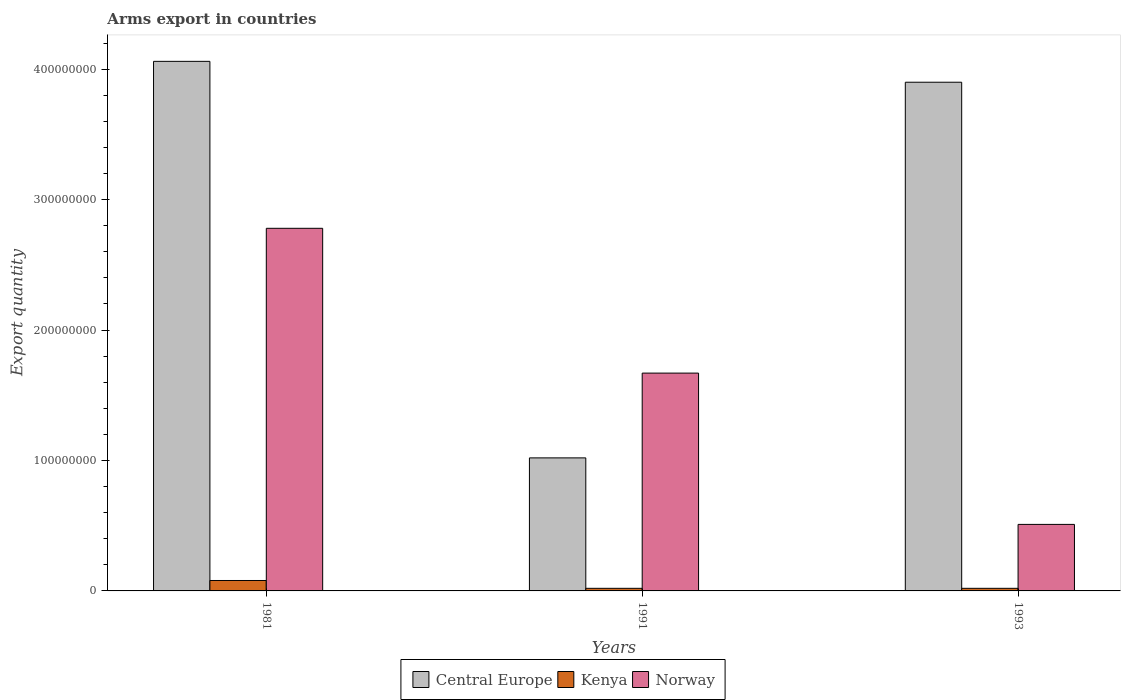How many different coloured bars are there?
Make the answer very short. 3. How many groups of bars are there?
Provide a succinct answer. 3. In how many cases, is the number of bars for a given year not equal to the number of legend labels?
Offer a very short reply. 0. What is the total arms export in Kenya in 1991?
Make the answer very short. 2.00e+06. Across all years, what is the minimum total arms export in Norway?
Provide a succinct answer. 5.10e+07. In which year was the total arms export in Norway maximum?
Your answer should be very brief. 1981. In which year was the total arms export in Central Europe minimum?
Ensure brevity in your answer.  1991. What is the total total arms export in Central Europe in the graph?
Keep it short and to the point. 8.98e+08. What is the difference between the total arms export in Central Europe in 1981 and that in 1991?
Ensure brevity in your answer.  3.04e+08. What is the difference between the total arms export in Kenya in 1981 and the total arms export in Norway in 1991?
Your answer should be very brief. -1.59e+08. What is the average total arms export in Central Europe per year?
Keep it short and to the point. 2.99e+08. In the year 1981, what is the difference between the total arms export in Central Europe and total arms export in Norway?
Offer a terse response. 1.28e+08. What is the ratio of the total arms export in Central Europe in 1981 to that in 1991?
Your answer should be very brief. 3.98. Is the total arms export in Kenya in 1981 less than that in 1991?
Your answer should be very brief. No. What is the difference between the highest and the lowest total arms export in Norway?
Your response must be concise. 2.27e+08. In how many years, is the total arms export in Central Europe greater than the average total arms export in Central Europe taken over all years?
Your answer should be very brief. 2. Is the sum of the total arms export in Central Europe in 1991 and 1993 greater than the maximum total arms export in Kenya across all years?
Offer a terse response. Yes. What does the 1st bar from the left in 1991 represents?
Your response must be concise. Central Europe. What does the 3rd bar from the right in 1981 represents?
Your answer should be compact. Central Europe. Is it the case that in every year, the sum of the total arms export in Norway and total arms export in Kenya is greater than the total arms export in Central Europe?
Give a very brief answer. No. Are all the bars in the graph horizontal?
Make the answer very short. No. Are the values on the major ticks of Y-axis written in scientific E-notation?
Offer a terse response. No. Does the graph contain grids?
Keep it short and to the point. No. Where does the legend appear in the graph?
Keep it short and to the point. Bottom center. How many legend labels are there?
Give a very brief answer. 3. How are the legend labels stacked?
Make the answer very short. Horizontal. What is the title of the graph?
Keep it short and to the point. Arms export in countries. What is the label or title of the Y-axis?
Offer a very short reply. Export quantity. What is the Export quantity in Central Europe in 1981?
Provide a succinct answer. 4.06e+08. What is the Export quantity of Norway in 1981?
Offer a very short reply. 2.78e+08. What is the Export quantity of Central Europe in 1991?
Offer a very short reply. 1.02e+08. What is the Export quantity in Kenya in 1991?
Provide a short and direct response. 2.00e+06. What is the Export quantity of Norway in 1991?
Make the answer very short. 1.67e+08. What is the Export quantity of Central Europe in 1993?
Provide a succinct answer. 3.90e+08. What is the Export quantity of Norway in 1993?
Your answer should be very brief. 5.10e+07. Across all years, what is the maximum Export quantity of Central Europe?
Your response must be concise. 4.06e+08. Across all years, what is the maximum Export quantity in Kenya?
Keep it short and to the point. 8.00e+06. Across all years, what is the maximum Export quantity in Norway?
Offer a terse response. 2.78e+08. Across all years, what is the minimum Export quantity of Central Europe?
Your answer should be very brief. 1.02e+08. Across all years, what is the minimum Export quantity of Norway?
Make the answer very short. 5.10e+07. What is the total Export quantity in Central Europe in the graph?
Give a very brief answer. 8.98e+08. What is the total Export quantity in Kenya in the graph?
Provide a succinct answer. 1.20e+07. What is the total Export quantity of Norway in the graph?
Offer a terse response. 4.96e+08. What is the difference between the Export quantity in Central Europe in 1981 and that in 1991?
Keep it short and to the point. 3.04e+08. What is the difference between the Export quantity of Norway in 1981 and that in 1991?
Keep it short and to the point. 1.11e+08. What is the difference between the Export quantity of Central Europe in 1981 and that in 1993?
Your answer should be very brief. 1.60e+07. What is the difference between the Export quantity of Kenya in 1981 and that in 1993?
Provide a short and direct response. 6.00e+06. What is the difference between the Export quantity in Norway in 1981 and that in 1993?
Your answer should be compact. 2.27e+08. What is the difference between the Export quantity in Central Europe in 1991 and that in 1993?
Keep it short and to the point. -2.88e+08. What is the difference between the Export quantity in Norway in 1991 and that in 1993?
Offer a terse response. 1.16e+08. What is the difference between the Export quantity of Central Europe in 1981 and the Export quantity of Kenya in 1991?
Provide a short and direct response. 4.04e+08. What is the difference between the Export quantity in Central Europe in 1981 and the Export quantity in Norway in 1991?
Your response must be concise. 2.39e+08. What is the difference between the Export quantity of Kenya in 1981 and the Export quantity of Norway in 1991?
Ensure brevity in your answer.  -1.59e+08. What is the difference between the Export quantity in Central Europe in 1981 and the Export quantity in Kenya in 1993?
Your response must be concise. 4.04e+08. What is the difference between the Export quantity in Central Europe in 1981 and the Export quantity in Norway in 1993?
Keep it short and to the point. 3.55e+08. What is the difference between the Export quantity of Kenya in 1981 and the Export quantity of Norway in 1993?
Ensure brevity in your answer.  -4.30e+07. What is the difference between the Export quantity in Central Europe in 1991 and the Export quantity in Kenya in 1993?
Ensure brevity in your answer.  1.00e+08. What is the difference between the Export quantity in Central Europe in 1991 and the Export quantity in Norway in 1993?
Offer a very short reply. 5.10e+07. What is the difference between the Export quantity in Kenya in 1991 and the Export quantity in Norway in 1993?
Make the answer very short. -4.90e+07. What is the average Export quantity in Central Europe per year?
Offer a terse response. 2.99e+08. What is the average Export quantity of Kenya per year?
Offer a terse response. 4.00e+06. What is the average Export quantity in Norway per year?
Offer a terse response. 1.65e+08. In the year 1981, what is the difference between the Export quantity of Central Europe and Export quantity of Kenya?
Give a very brief answer. 3.98e+08. In the year 1981, what is the difference between the Export quantity in Central Europe and Export quantity in Norway?
Ensure brevity in your answer.  1.28e+08. In the year 1981, what is the difference between the Export quantity in Kenya and Export quantity in Norway?
Keep it short and to the point. -2.70e+08. In the year 1991, what is the difference between the Export quantity of Central Europe and Export quantity of Norway?
Your answer should be very brief. -6.50e+07. In the year 1991, what is the difference between the Export quantity in Kenya and Export quantity in Norway?
Your answer should be very brief. -1.65e+08. In the year 1993, what is the difference between the Export quantity of Central Europe and Export quantity of Kenya?
Provide a succinct answer. 3.88e+08. In the year 1993, what is the difference between the Export quantity in Central Europe and Export quantity in Norway?
Offer a very short reply. 3.39e+08. In the year 1993, what is the difference between the Export quantity of Kenya and Export quantity of Norway?
Your answer should be very brief. -4.90e+07. What is the ratio of the Export quantity in Central Europe in 1981 to that in 1991?
Your response must be concise. 3.98. What is the ratio of the Export quantity of Kenya in 1981 to that in 1991?
Offer a very short reply. 4. What is the ratio of the Export quantity in Norway in 1981 to that in 1991?
Your answer should be very brief. 1.66. What is the ratio of the Export quantity in Central Europe in 1981 to that in 1993?
Your response must be concise. 1.04. What is the ratio of the Export quantity in Kenya in 1981 to that in 1993?
Make the answer very short. 4. What is the ratio of the Export quantity in Norway in 1981 to that in 1993?
Keep it short and to the point. 5.45. What is the ratio of the Export quantity in Central Europe in 1991 to that in 1993?
Provide a succinct answer. 0.26. What is the ratio of the Export quantity in Norway in 1991 to that in 1993?
Ensure brevity in your answer.  3.27. What is the difference between the highest and the second highest Export quantity of Central Europe?
Your answer should be very brief. 1.60e+07. What is the difference between the highest and the second highest Export quantity of Norway?
Give a very brief answer. 1.11e+08. What is the difference between the highest and the lowest Export quantity of Central Europe?
Provide a succinct answer. 3.04e+08. What is the difference between the highest and the lowest Export quantity in Kenya?
Keep it short and to the point. 6.00e+06. What is the difference between the highest and the lowest Export quantity in Norway?
Ensure brevity in your answer.  2.27e+08. 